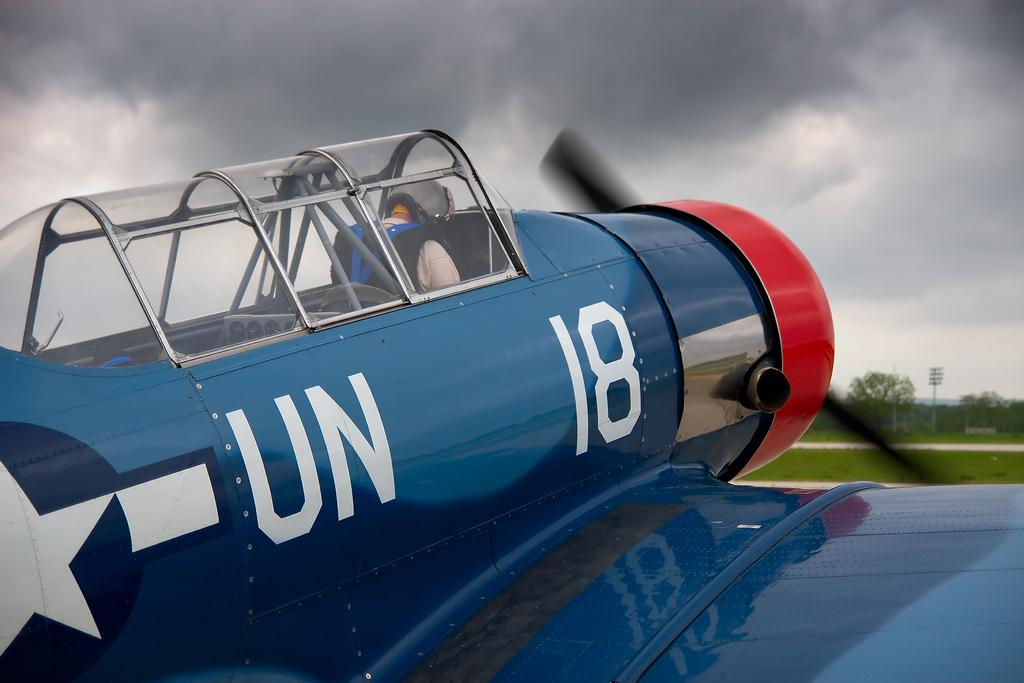<image>
Offer a succinct explanation of the picture presented. a pilot plane in blue from the UN and number 18 